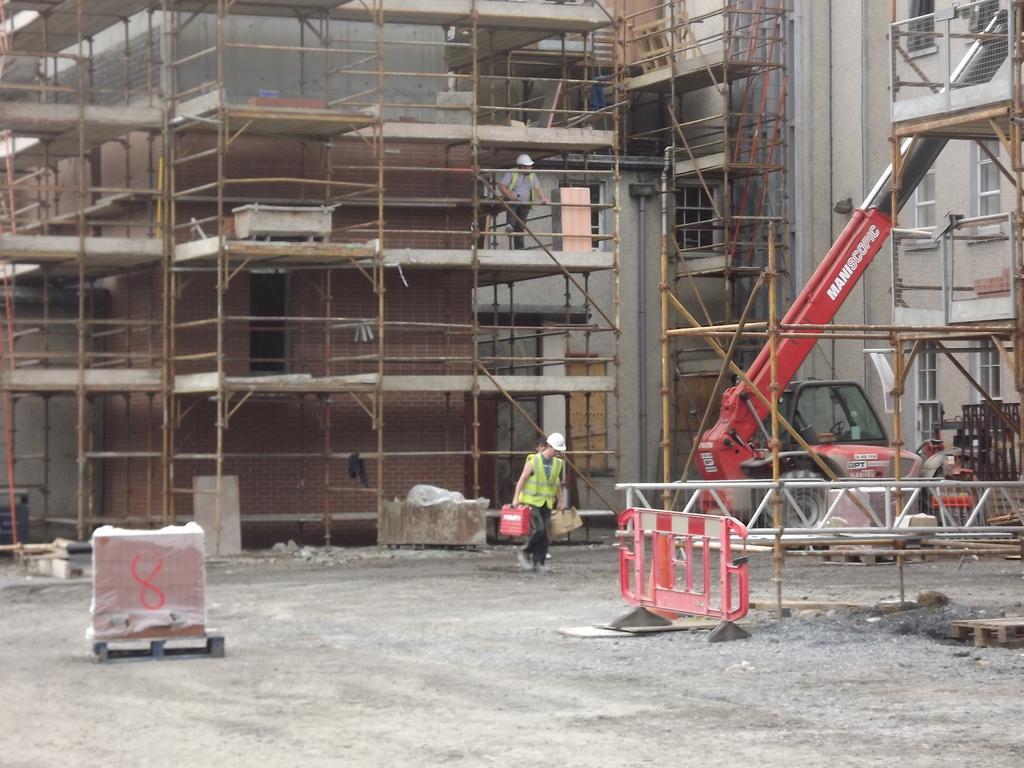Please provide a concise description of this image. In this image I can see the ground, few metal rods, a person standing and holding few objects, a crane which is red and black in color and few buildings which are under constructions. I can see a person standing in the building. 